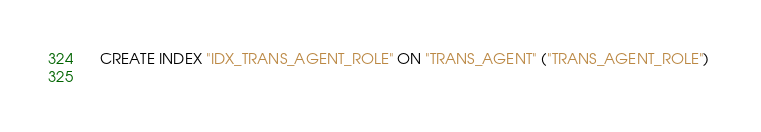<code> <loc_0><loc_0><loc_500><loc_500><_SQL_>
  CREATE INDEX "IDX_TRANS_AGENT_ROLE" ON "TRANS_AGENT" ("TRANS_AGENT_ROLE") 
  </code> 